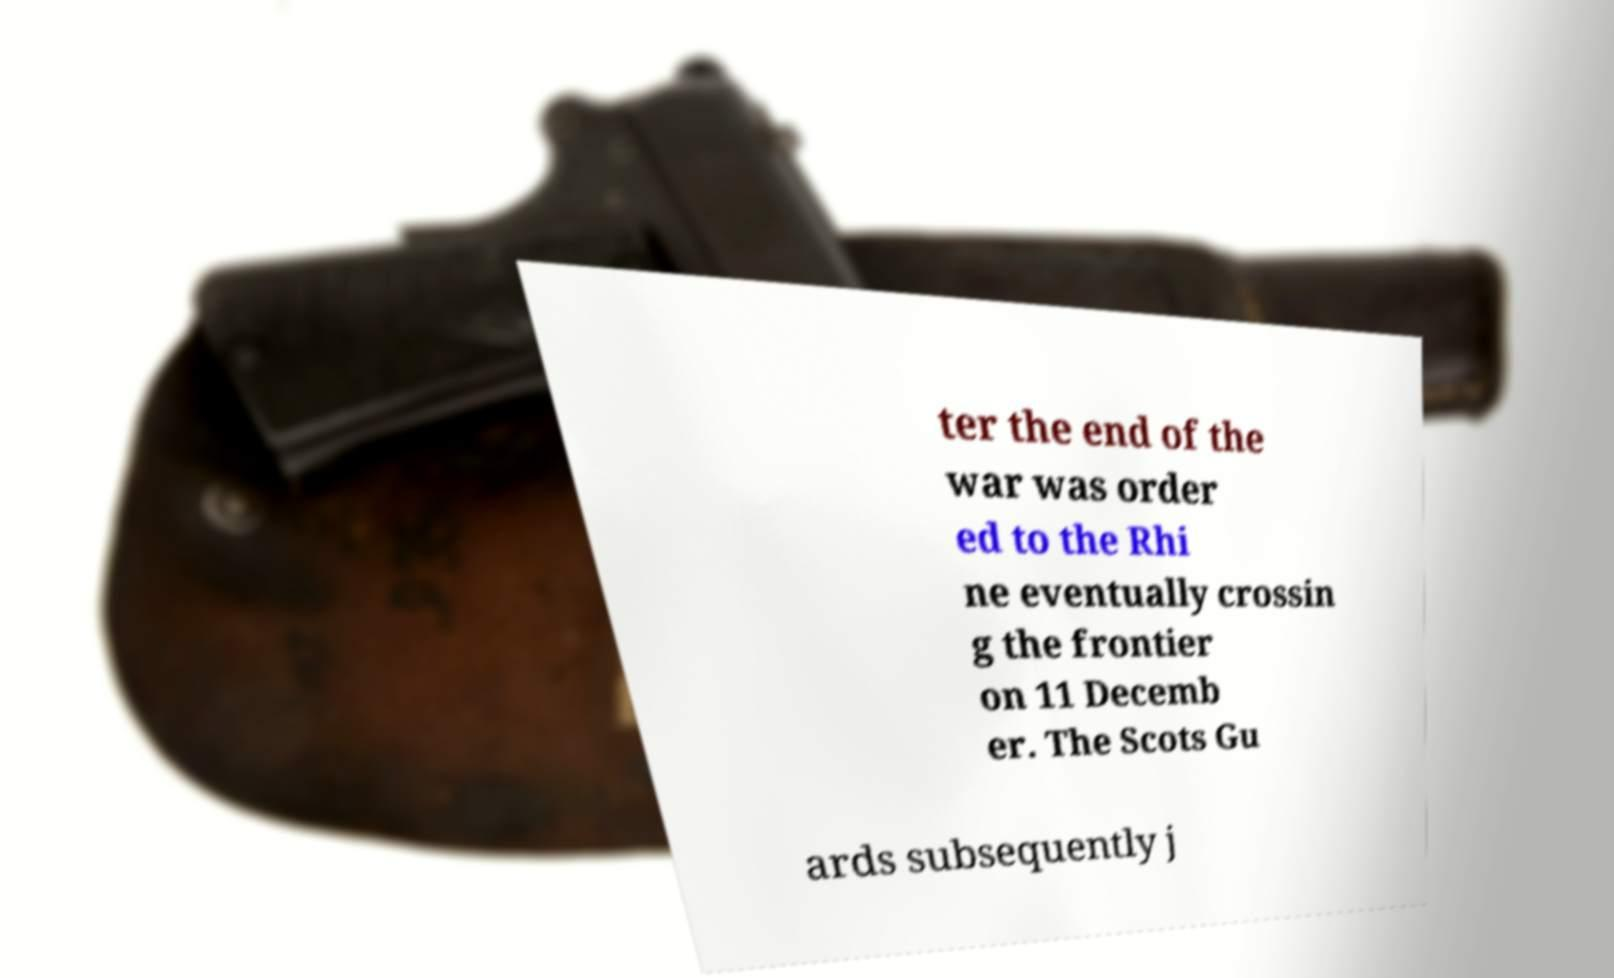Please identify and transcribe the text found in this image. ter the end of the war was order ed to the Rhi ne eventually crossin g the frontier on 11 Decemb er. The Scots Gu ards subsequently j 